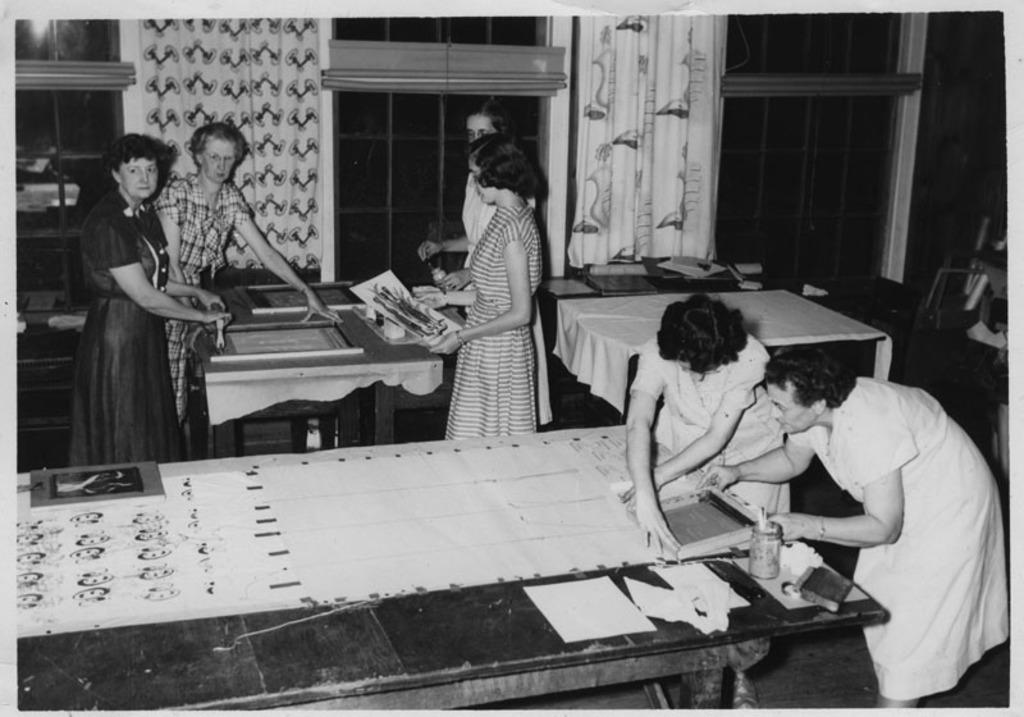How many people are in the image? There is a group of people in the image, but the exact number is not specified. What are the people doing in the image? The people are standing with tables in front of them and doing something on the tables. What can be seen in the background of the image? There are curtains present in the background of the image. What type of match is being played on the tables in the image? There is no indication of a match being played in the image; the people are simply doing something on the tables. How does the coal affect the development of the people in the image? There is no coal present in the image, and therefore no impact on the development of the people can be determined. 